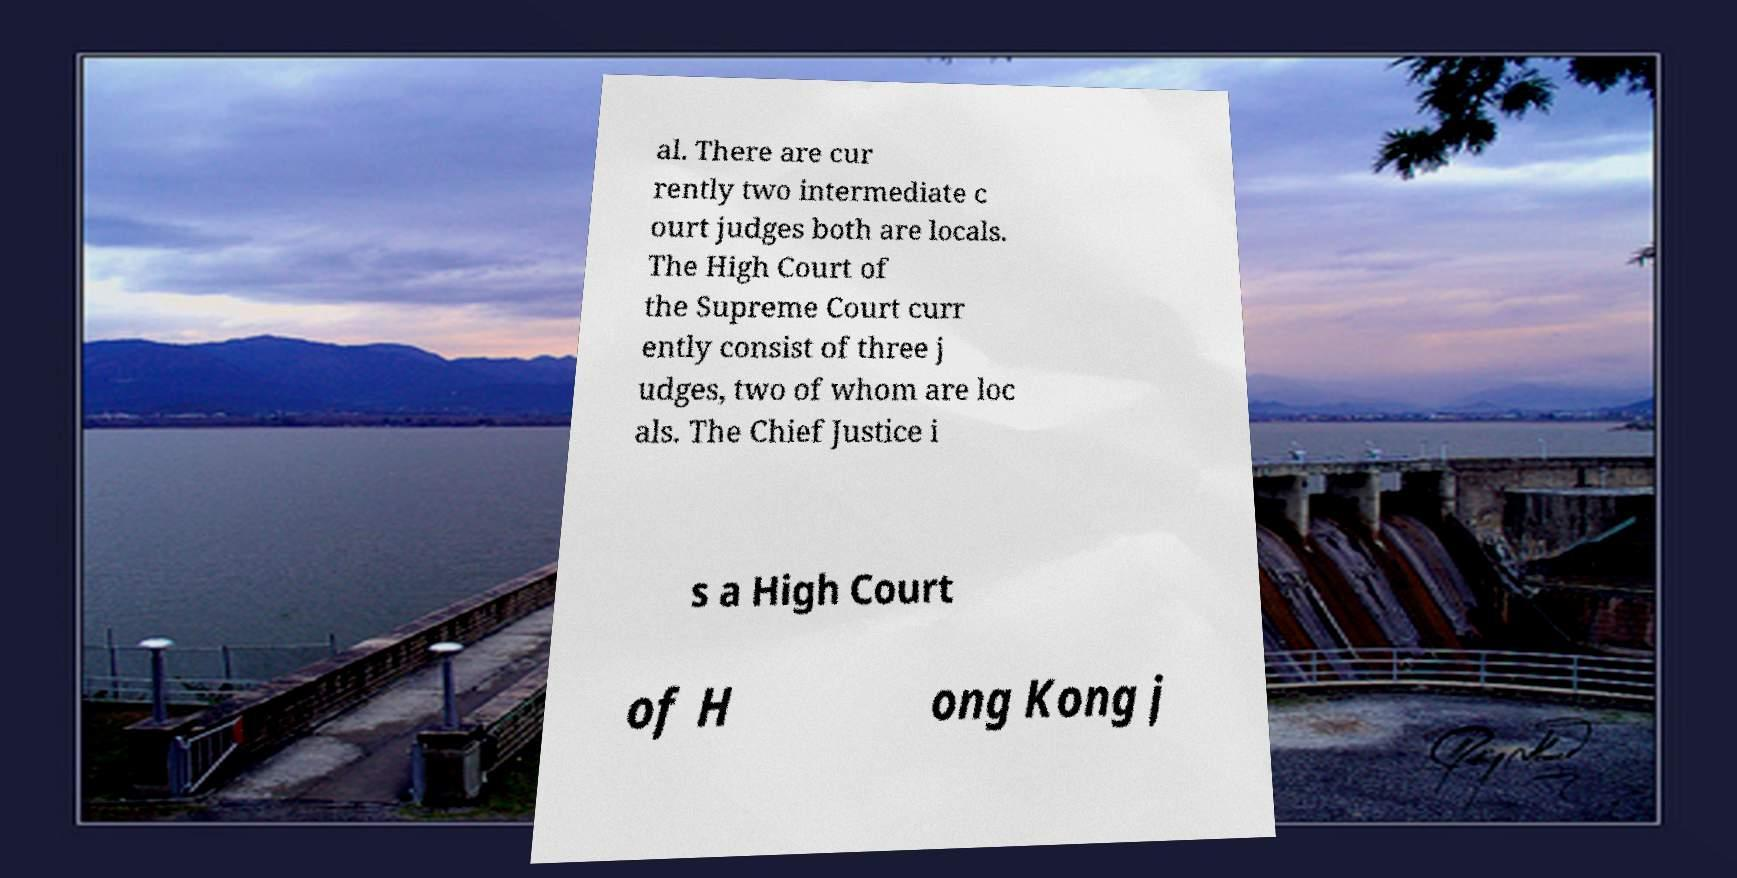Could you assist in decoding the text presented in this image and type it out clearly? al. There are cur rently two intermediate c ourt judges both are locals. The High Court of the Supreme Court curr ently consist of three j udges, two of whom are loc als. The Chief Justice i s a High Court of H ong Kong j 